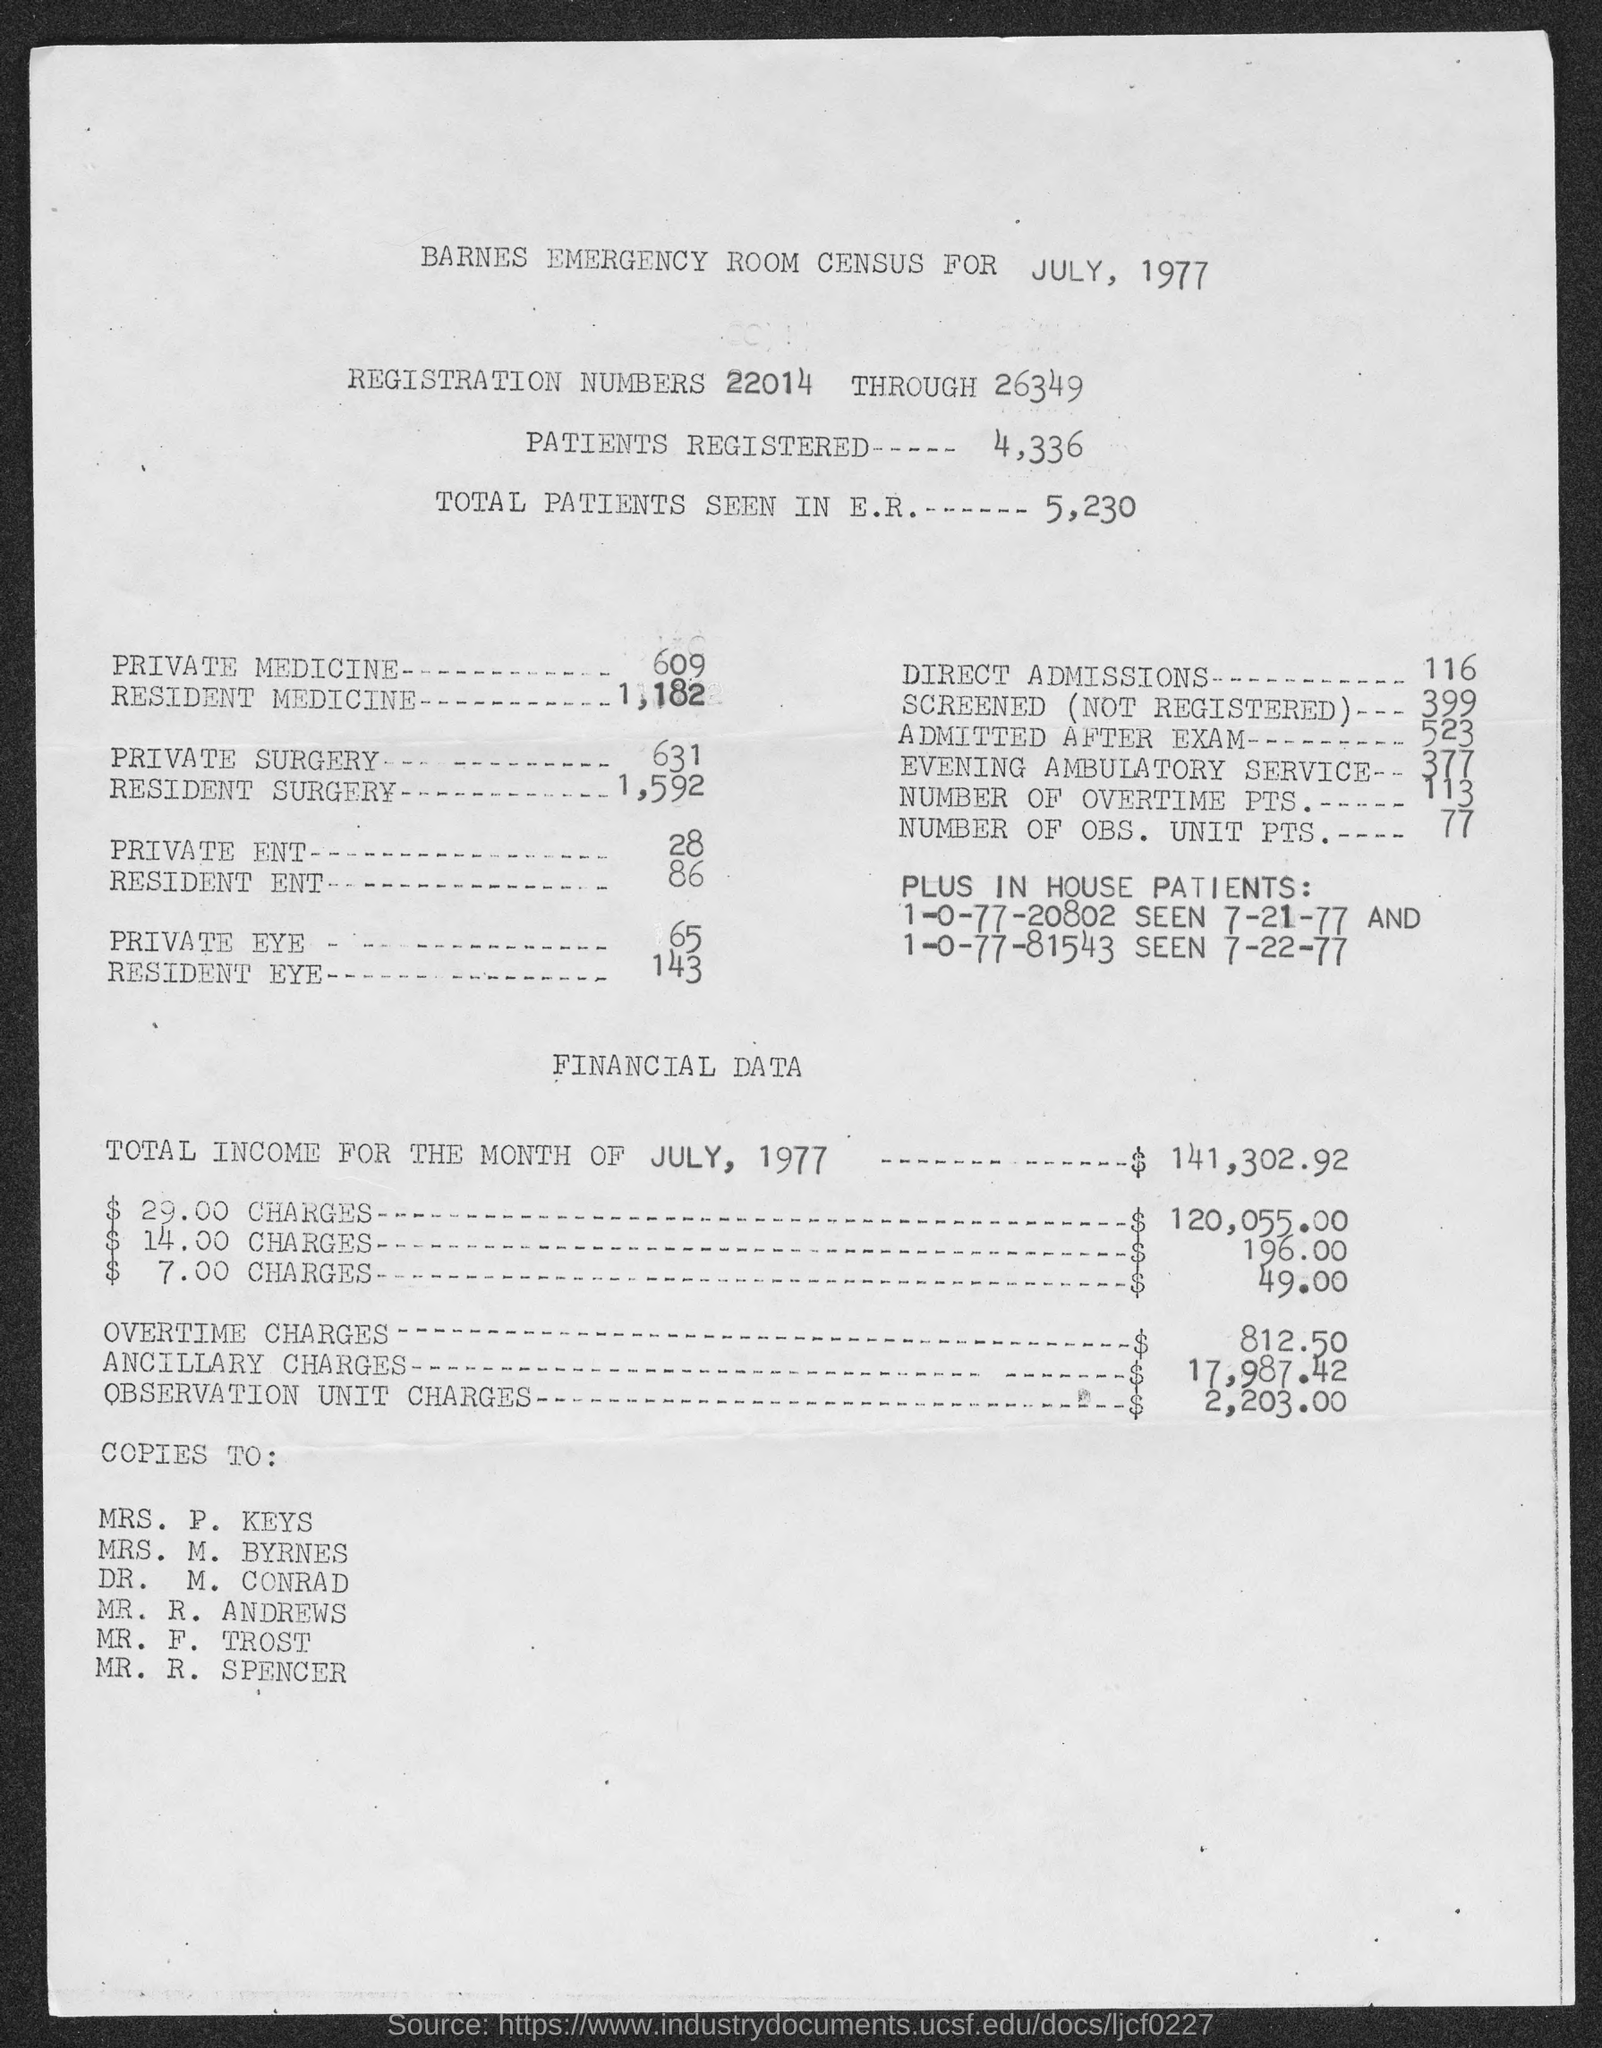What is the date on the document?
Keep it short and to the point. July, 1977. How many petients registered?
Your response must be concise. 4,336. What are the total patients seen in E.R.?
Provide a short and direct response. 5,230. How many Direct admissions?
Make the answer very short. 116. How many admitted after exam??
Provide a succinct answer. 523. What is the Total Income for the month of July, 1977?
Your answer should be very brief. $ 141,302.92. What are the Overtime charges?
Your answer should be compact. $ 812.50. What are the Ancillary charges?
Ensure brevity in your answer.  $17,987.42. What are the Observation Unit charges?
Give a very brief answer. $2,203.00. How many Number of Overtime Pts.?
Offer a terse response. 113. 